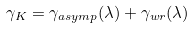<formula> <loc_0><loc_0><loc_500><loc_500>\gamma _ { K } = \gamma _ { a s y m p } ( \lambda ) + \gamma _ { w r } ( \lambda )</formula> 